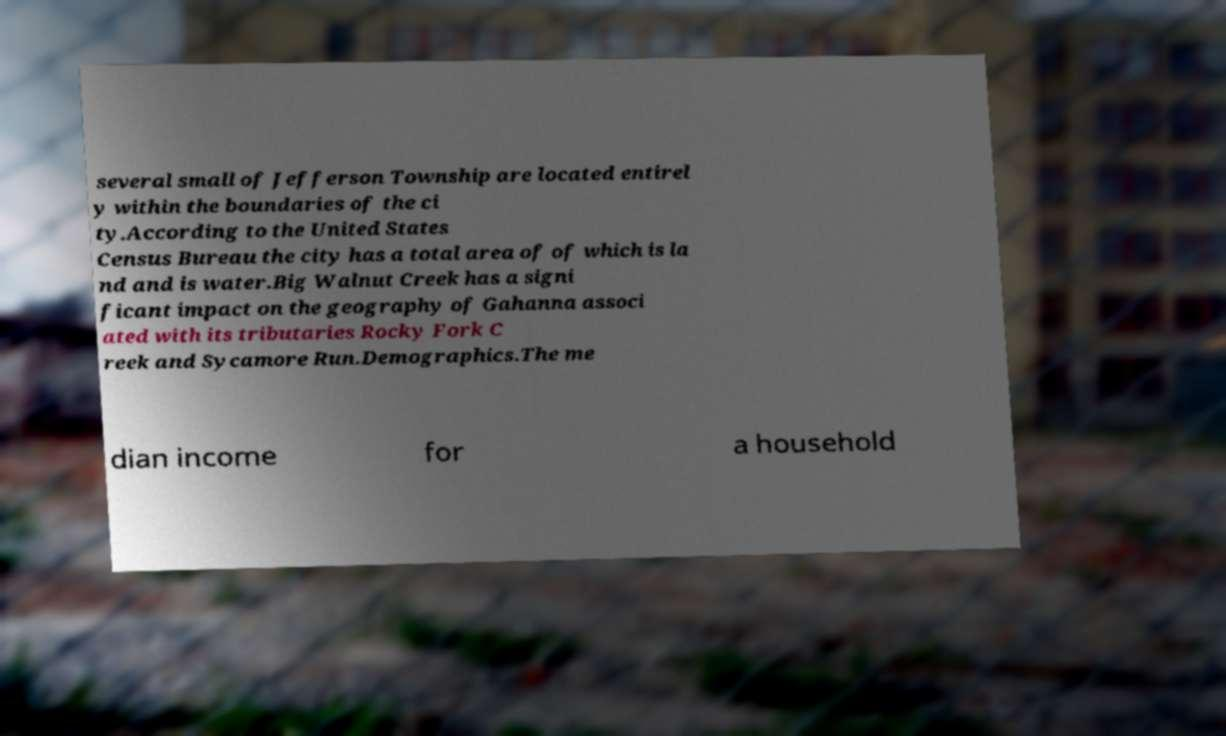Could you assist in decoding the text presented in this image and type it out clearly? several small of Jefferson Township are located entirel y within the boundaries of the ci ty.According to the United States Census Bureau the city has a total area of of which is la nd and is water.Big Walnut Creek has a signi ficant impact on the geography of Gahanna associ ated with its tributaries Rocky Fork C reek and Sycamore Run.Demographics.The me dian income for a household 